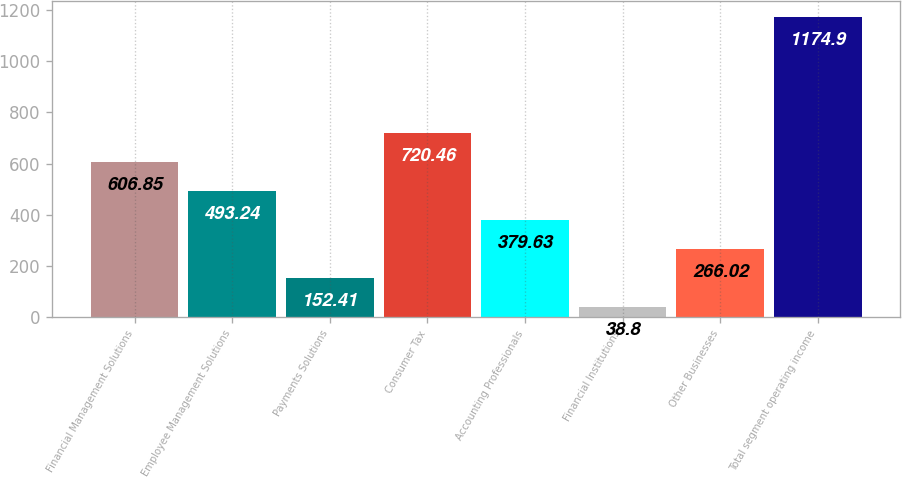Convert chart. <chart><loc_0><loc_0><loc_500><loc_500><bar_chart><fcel>Financial Management Solutions<fcel>Employee Management Solutions<fcel>Payments Solutions<fcel>Consumer Tax<fcel>Accounting Professionals<fcel>Financial Institutions<fcel>Other Businesses<fcel>Total segment operating income<nl><fcel>606.85<fcel>493.24<fcel>152.41<fcel>720.46<fcel>379.63<fcel>38.8<fcel>266.02<fcel>1174.9<nl></chart> 